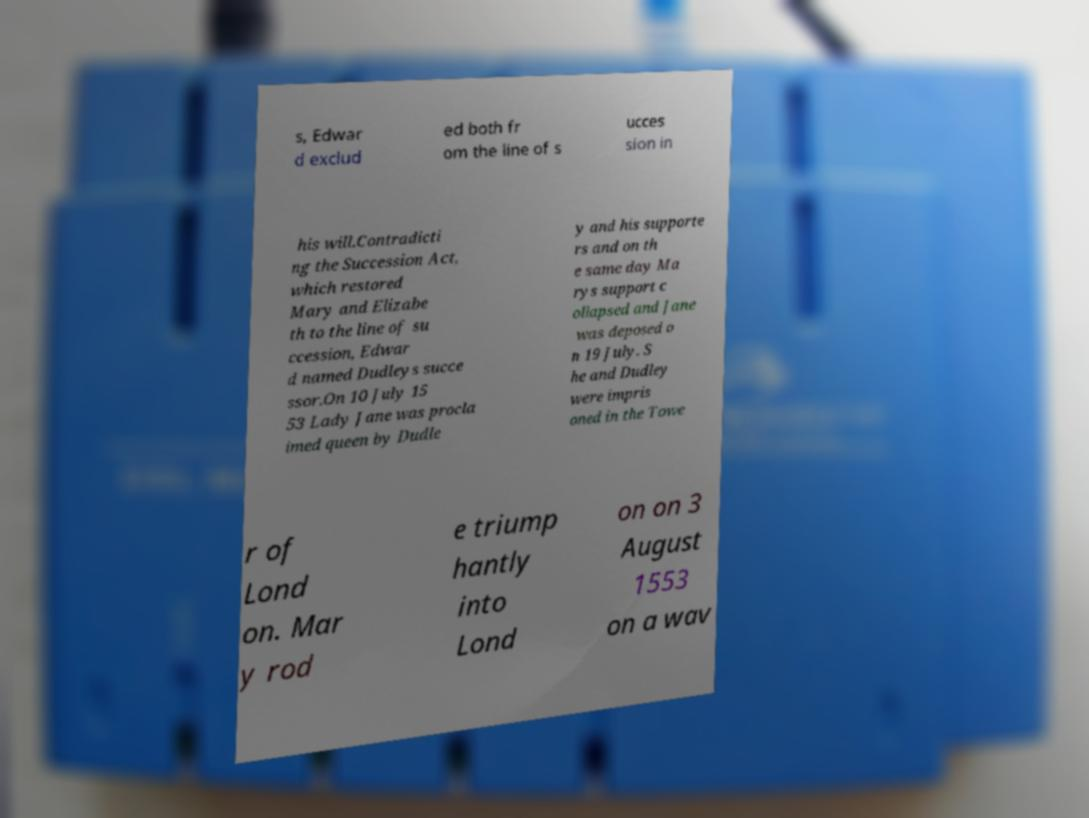Can you accurately transcribe the text from the provided image for me? s, Edwar d exclud ed both fr om the line of s ucces sion in his will.Contradicti ng the Succession Act, which restored Mary and Elizabe th to the line of su ccession, Edwar d named Dudleys succe ssor.On 10 July 15 53 Lady Jane was procla imed queen by Dudle y and his supporte rs and on th e same day Ma rys support c ollapsed and Jane was deposed o n 19 July. S he and Dudley were impris oned in the Towe r of Lond on. Mar y rod e triump hantly into Lond on on 3 August 1553 on a wav 